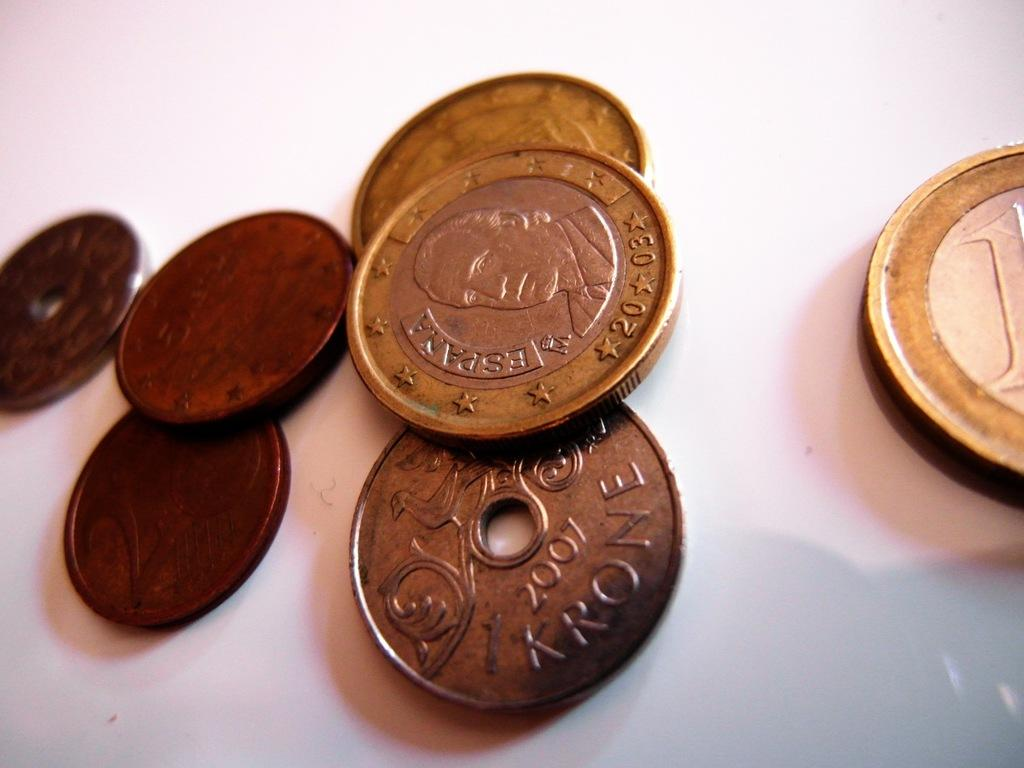<image>
Summarize the visual content of the image. the year 2007 is on the coin face 